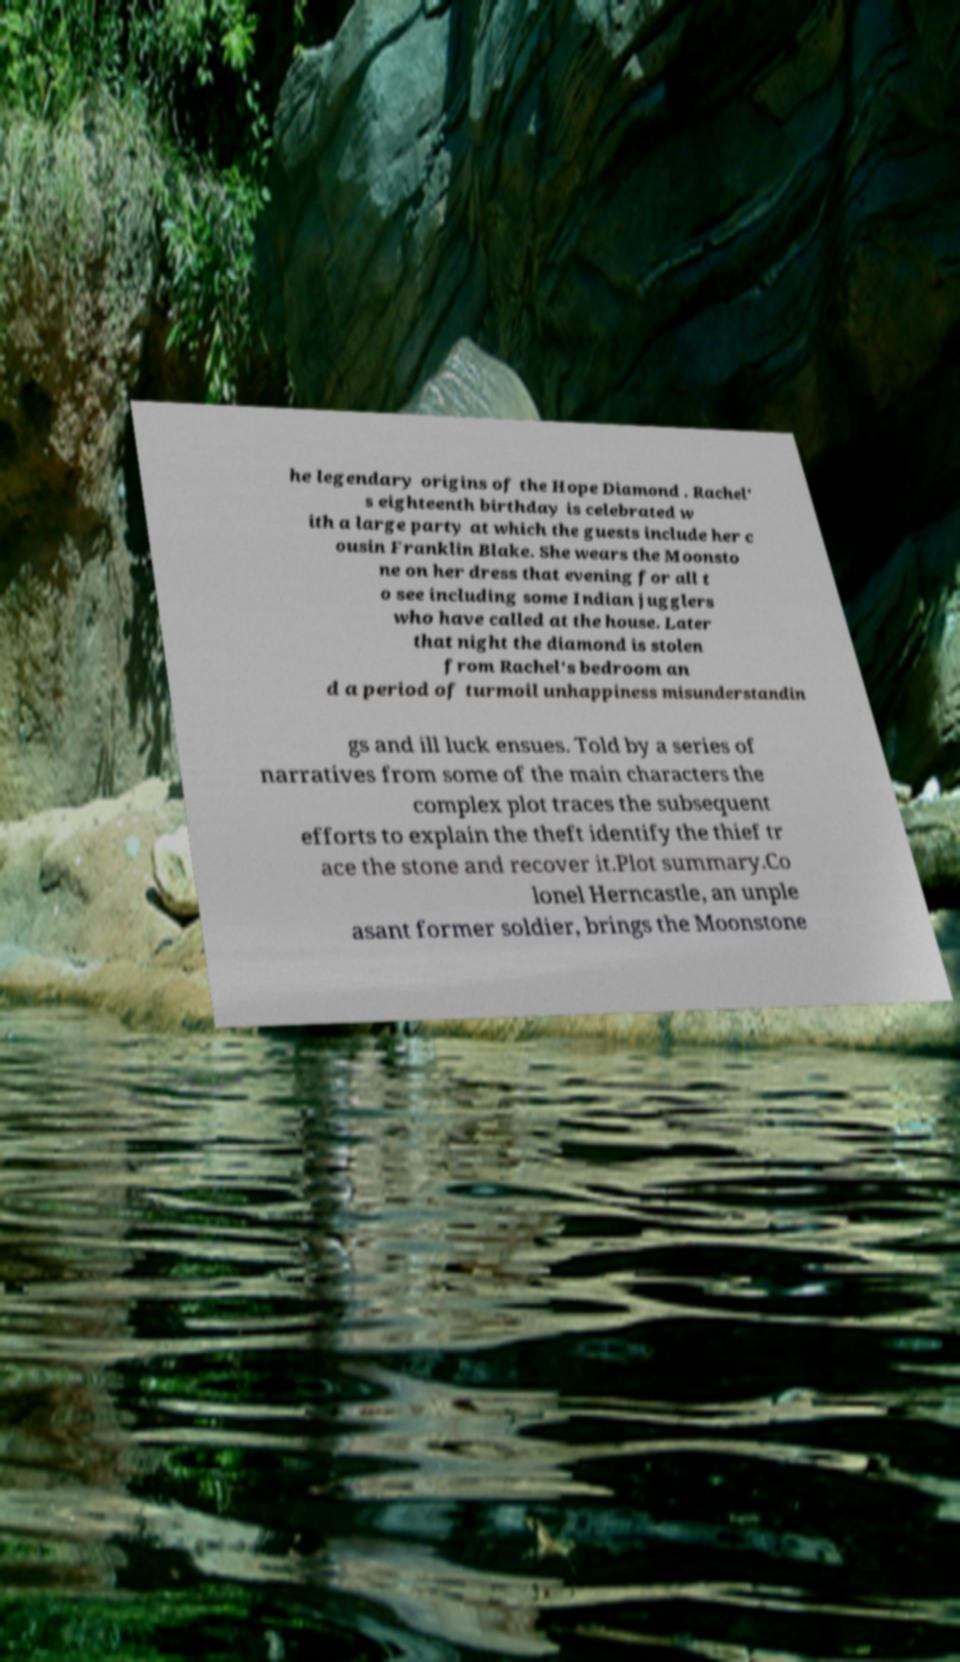Can you accurately transcribe the text from the provided image for me? he legendary origins of the Hope Diamond . Rachel' s eighteenth birthday is celebrated w ith a large party at which the guests include her c ousin Franklin Blake. She wears the Moonsto ne on her dress that evening for all t o see including some Indian jugglers who have called at the house. Later that night the diamond is stolen from Rachel's bedroom an d a period of turmoil unhappiness misunderstandin gs and ill luck ensues. Told by a series of narratives from some of the main characters the complex plot traces the subsequent efforts to explain the theft identify the thief tr ace the stone and recover it.Plot summary.Co lonel Herncastle, an unple asant former soldier, brings the Moonstone 